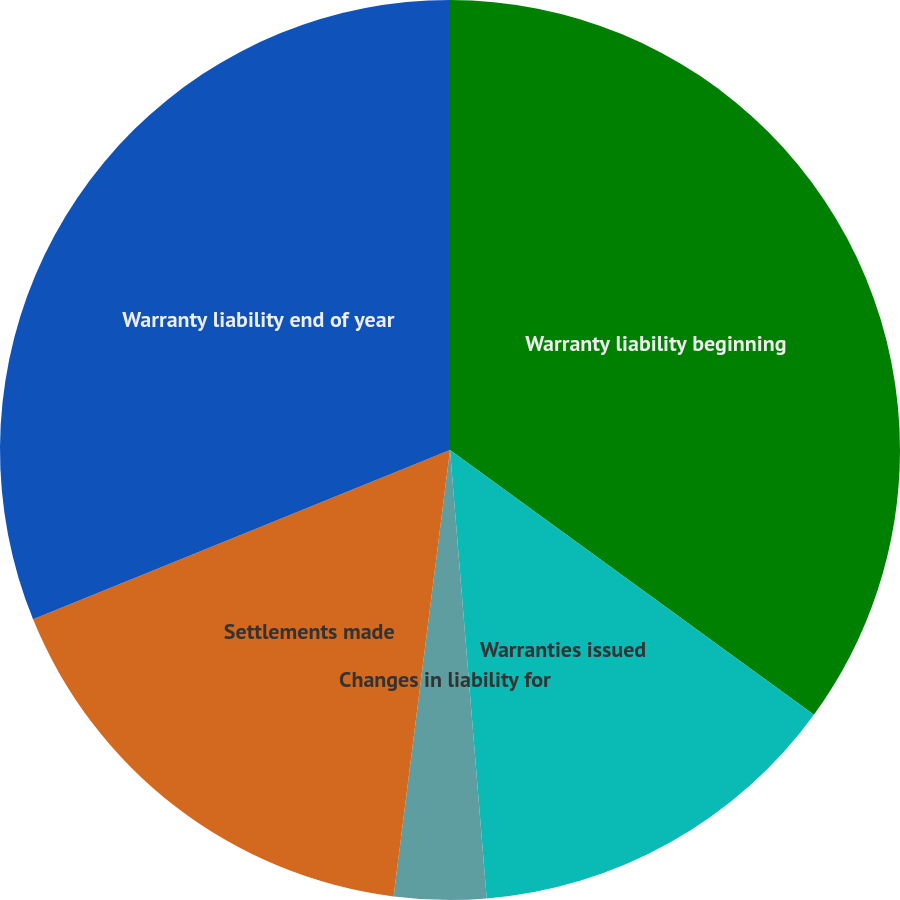Convert chart. <chart><loc_0><loc_0><loc_500><loc_500><pie_chart><fcel>Warranty liability beginning<fcel>Warranties issued<fcel>Changes in liability for<fcel>Settlements made<fcel>Warranty liability end of year<nl><fcel>35.01%<fcel>13.69%<fcel>3.3%<fcel>16.86%<fcel>31.14%<nl></chart> 